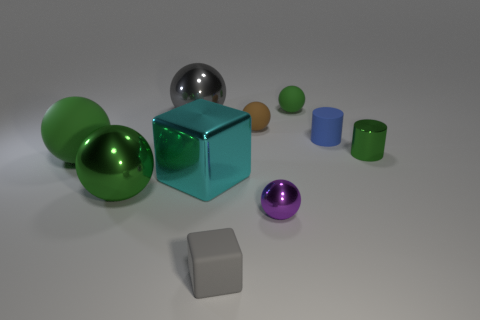Subtract all green cubes. How many green spheres are left? 3 Subtract all green spheres. How many spheres are left? 3 Subtract all small rubber spheres. How many spheres are left? 4 Subtract all yellow balls. Subtract all purple blocks. How many balls are left? 6 Subtract all cylinders. How many objects are left? 8 Add 6 tiny metallic objects. How many tiny metallic objects are left? 8 Add 3 big green matte blocks. How many big green matte blocks exist? 3 Subtract 0 purple cubes. How many objects are left? 10 Subtract all cyan shiny cubes. Subtract all brown matte cubes. How many objects are left? 9 